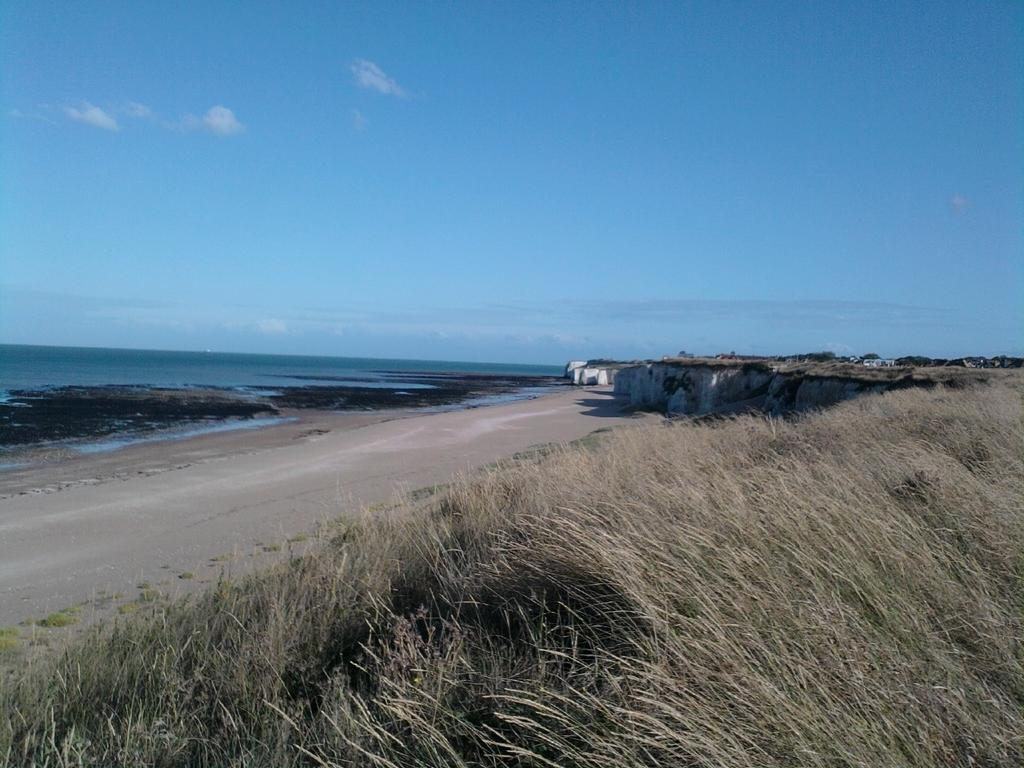What type of natural environment is present in the image? There is grass in the image. What type of man-made structure can be seen in the image? There is a road and a wall in the image. What natural element is visible in the image? There is water visible in the image. What is visible in the background of the image? The sky is visible in the background of the image, and there are clouds in the sky. Where is the flame located in the image? There is no flame present in the image. What type of seat can be seen in the image? There is no seat present in the image. 